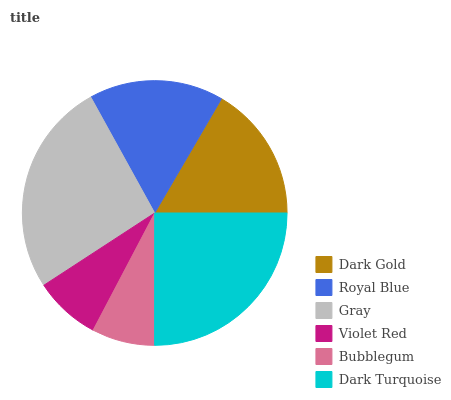Is Bubblegum the minimum?
Answer yes or no. Yes. Is Gray the maximum?
Answer yes or no. Yes. Is Royal Blue the minimum?
Answer yes or no. No. Is Royal Blue the maximum?
Answer yes or no. No. Is Dark Gold greater than Royal Blue?
Answer yes or no. Yes. Is Royal Blue less than Dark Gold?
Answer yes or no. Yes. Is Royal Blue greater than Dark Gold?
Answer yes or no. No. Is Dark Gold less than Royal Blue?
Answer yes or no. No. Is Dark Gold the high median?
Answer yes or no. Yes. Is Royal Blue the low median?
Answer yes or no. Yes. Is Royal Blue the high median?
Answer yes or no. No. Is Gray the low median?
Answer yes or no. No. 